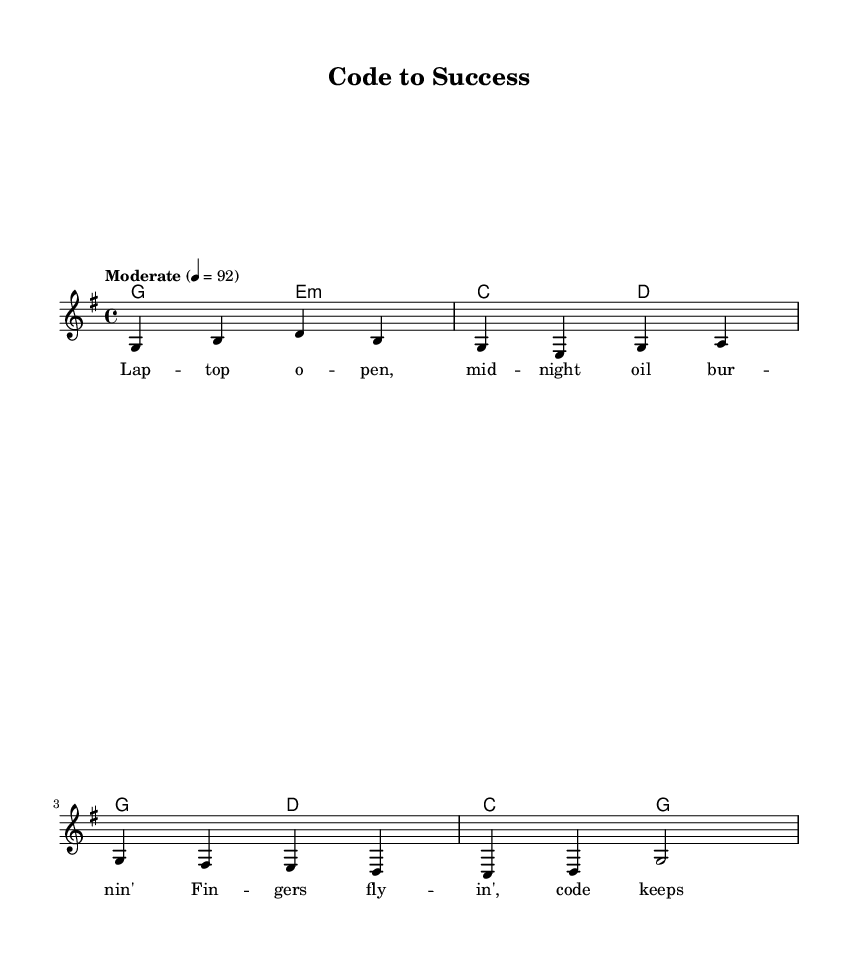What is the key signature of this music? The key signature is G major, which has one sharp (F#). This can be identified at the beginning of the sheet music where the key signature is indicated.
Answer: G major What is the time signature of this music? The time signature is 4/4, which means there are four beats in each measure and the quarter note gets one beat. This information is located at the beginning of the sheet music as well.
Answer: 4/4 What is the tempo marking for this piece? The tempo marking is "Moderate," which indicates the piece should be played at a moderate speed; the specific metronome marking of 92 beats per minute is also mentioned.
Answer: Moderate How many measures are in the melody section? There are four measures in the melody section, identifiable by counting the vertical lines that separate the measures in the staff.
Answer: 4 What is the first chord in the verse? The first chord in the verse is G major, which is found at the beginning of the chord section and is the first chord indicated in the chord changes for the verse.
Answer: G major What is the main theme expressed in the lyrics of the chorus? The main theme of the chorus is about striving for success in academics, as reflected in phrases like "Com pilin' dreams" and "Racin' to the top of the class." The lyrics suggest a relentless pursuit of academic excellence, which is central to the song’s message.
Answer: Success in academics How many beats does each measure in the chorus contain? Each measure in the chorus contains four beats, which can be determined by looking at the time signature (4/4) that applies to this section as well.
Answer: 4 